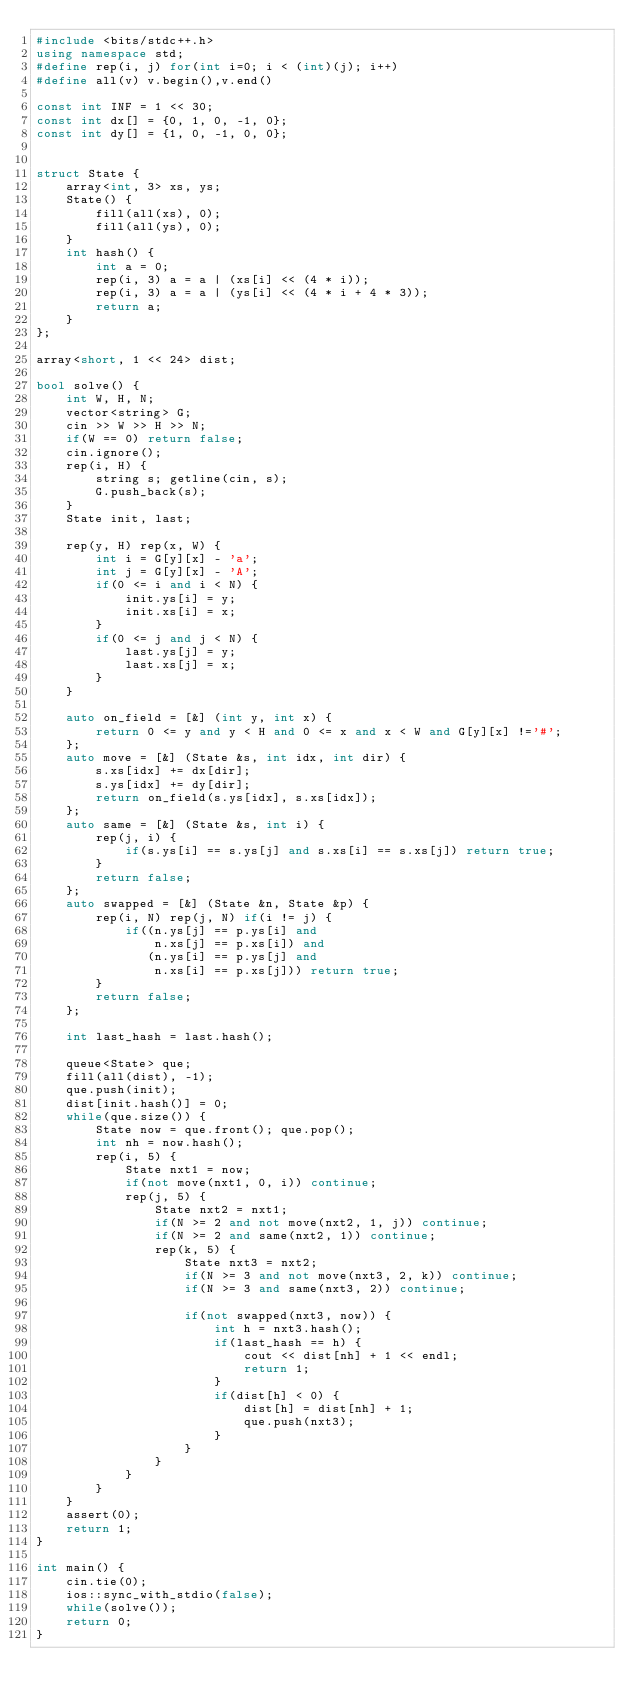Convert code to text. <code><loc_0><loc_0><loc_500><loc_500><_C++_>#include <bits/stdc++.h>
using namespace std;
#define rep(i, j) for(int i=0; i < (int)(j); i++)
#define all(v) v.begin(),v.end()

const int INF = 1 << 30;
const int dx[] = {0, 1, 0, -1, 0};
const int dy[] = {1, 0, -1, 0, 0};


struct State {
    array<int, 3> xs, ys;
    State() {
        fill(all(xs), 0);
        fill(all(ys), 0);
    }
    int hash() {
        int a = 0;
        rep(i, 3) a = a | (xs[i] << (4 * i));
        rep(i, 3) a = a | (ys[i] << (4 * i + 4 * 3));
        return a;
    }
};

array<short, 1 << 24> dist;

bool solve() {
    int W, H, N; 
    vector<string> G;    
    cin >> W >> H >> N;
    if(W == 0) return false;
    cin.ignore();
    rep(i, H) {
        string s; getline(cin, s);
        G.push_back(s);
    }
    State init, last;    
    
    rep(y, H) rep(x, W) {
        int i = G[y][x] - 'a';
        int j = G[y][x] - 'A';
        if(0 <= i and i < N) {
            init.ys[i] = y;
            init.xs[i] = x;
        }
        if(0 <= j and j < N) {
            last.ys[j] = y;
            last.xs[j] = x;
        }
    }
    
    auto on_field = [&] (int y, int x) {
        return 0 <= y and y < H and 0 <= x and x < W and G[y][x] !='#';
    };
    auto move = [&] (State &s, int idx, int dir) {
        s.xs[idx] += dx[dir];
        s.ys[idx] += dy[dir];
        return on_field(s.ys[idx], s.xs[idx]);
    };
    auto same = [&] (State &s, int i) {
        rep(j, i) {
            if(s.ys[i] == s.ys[j] and s.xs[i] == s.xs[j]) return true;
        }
        return false;
    };
    auto swapped = [&] (State &n, State &p) {
        rep(i, N) rep(j, N) if(i != j) {
            if((n.ys[j] == p.ys[i] and
                n.xs[j] == p.xs[i]) and
               (n.ys[i] == p.ys[j] and
                n.xs[i] == p.xs[j])) return true;
        }
        return false;
    };

    int last_hash = last.hash();

    queue<State> que;
    fill(all(dist), -1);
    que.push(init);
    dist[init.hash()] = 0;
    while(que.size()) {
        State now = que.front(); que.pop();
        int nh = now.hash();
        rep(i, 5) {
            State nxt1 = now;
            if(not move(nxt1, 0, i)) continue;
            rep(j, 5) {
                State nxt2 = nxt1;
                if(N >= 2 and not move(nxt2, 1, j)) continue;
                if(N >= 2 and same(nxt2, 1)) continue;
                rep(k, 5) {
                    State nxt3 = nxt2;
                    if(N >= 3 and not move(nxt3, 2, k)) continue;
                    if(N >= 3 and same(nxt3, 2)) continue;
                    
                    if(not swapped(nxt3, now)) {
                        int h = nxt3.hash();
                        if(last_hash == h) {
                            cout << dist[nh] + 1 << endl;
                            return 1;
                        }
                        if(dist[h] < 0) {
                            dist[h] = dist[nh] + 1;
                            que.push(nxt3);
                        }
                    }                    
                }
            }
        }
    }
    assert(0);
    return 1;
}

int main() {
    cin.tie(0);
    ios::sync_with_stdio(false);
    while(solve());
    return 0;
}</code> 